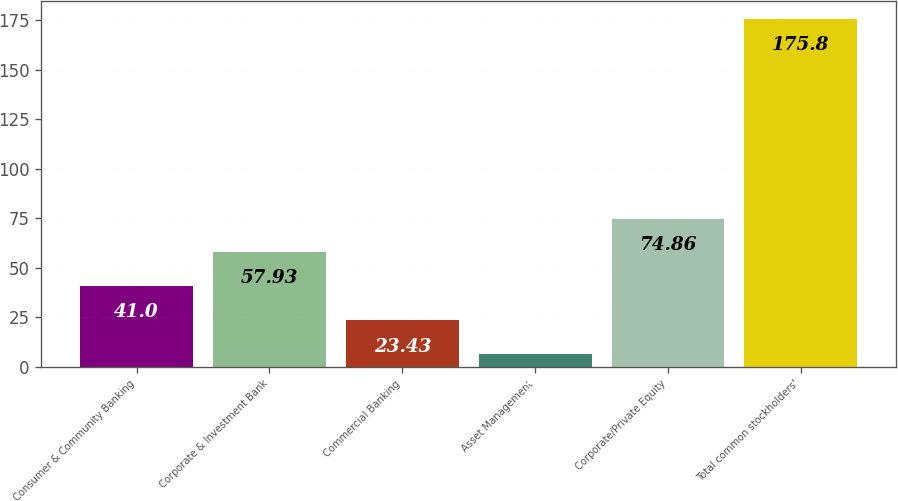Convert chart. <chart><loc_0><loc_0><loc_500><loc_500><bar_chart><fcel>Consumer & Community Banking<fcel>Corporate & Investment Bank<fcel>Commercial Banking<fcel>Asset Management<fcel>Corporate/Private Equity<fcel>Total common stockholders'<nl><fcel>41<fcel>57.93<fcel>23.43<fcel>6.5<fcel>74.86<fcel>175.8<nl></chart> 